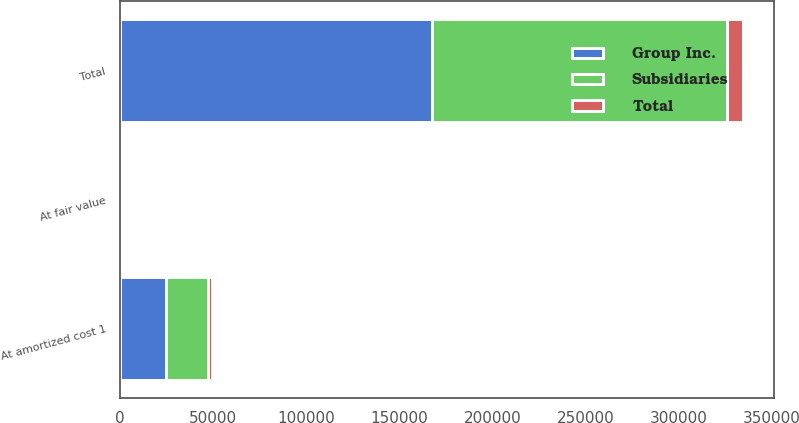<chart> <loc_0><loc_0><loc_500><loc_500><stacked_bar_chart><ecel><fcel>At fair value<fcel>At amortized cost 1<fcel>Total<nl><fcel>Subsidiaries<fcel>28<fcel>22500<fcel>158679<nl><fcel>Total<fcel>94<fcel>2047<fcel>8626<nl><fcel>Group Inc.<fcel>122<fcel>24547<fcel>167305<nl></chart> 